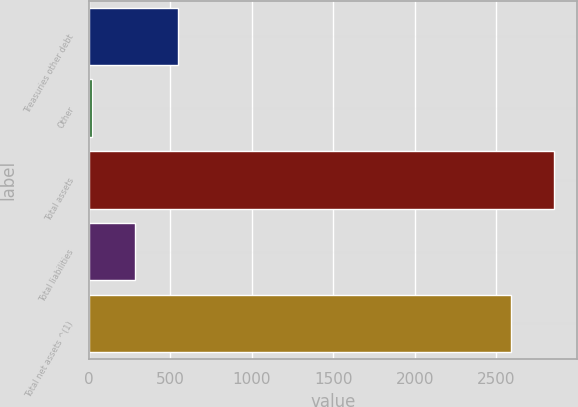Convert chart to OTSL. <chart><loc_0><loc_0><loc_500><loc_500><bar_chart><fcel>Treasuries other debt<fcel>Other<fcel>Total assets<fcel>Total liabilities<fcel>Total net assets ^(1)<nl><fcel>546<fcel>17<fcel>2852.5<fcel>281.5<fcel>2588<nl></chart> 